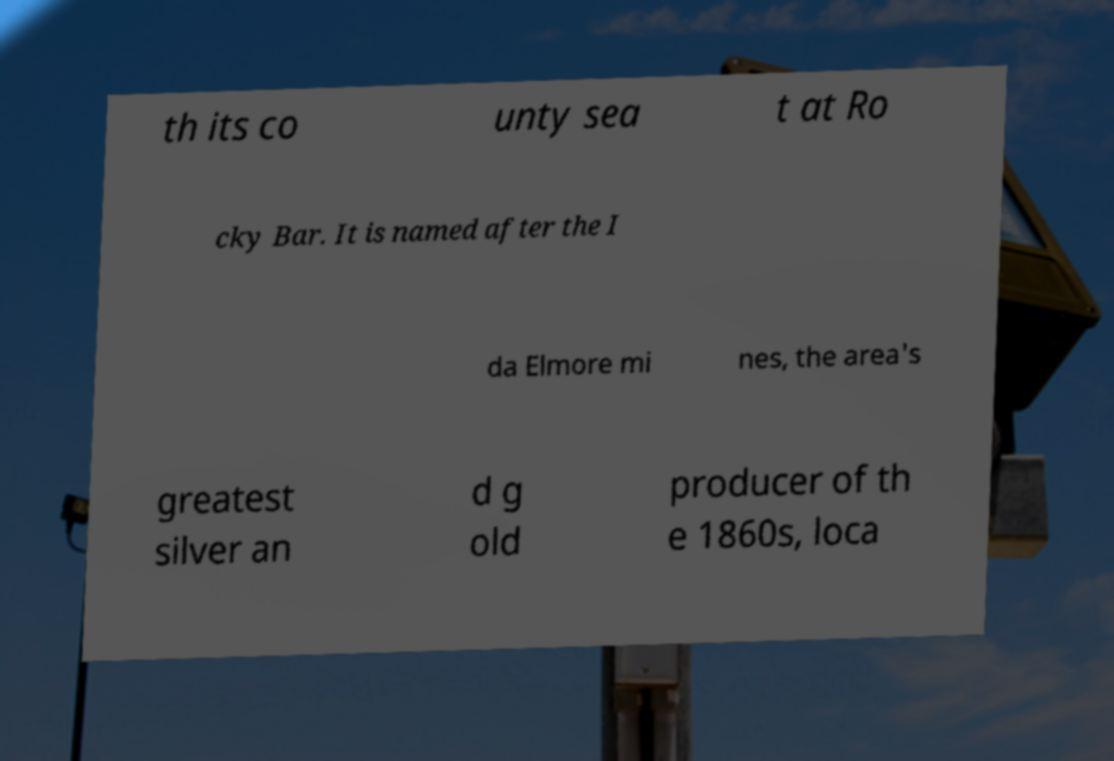Can you accurately transcribe the text from the provided image for me? th its co unty sea t at Ro cky Bar. It is named after the I da Elmore mi nes, the area's greatest silver an d g old producer of th e 1860s, loca 